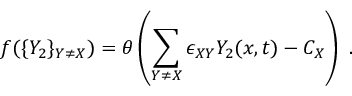Convert formula to latex. <formula><loc_0><loc_0><loc_500><loc_500>f ( \{ Y _ { 2 } \} _ { Y \neq X } ) = \boldsymbol \theta \left ( \sum _ { Y \neq X } \epsilon _ { X Y } Y _ { 2 } ( x , t ) - C _ { X } \right ) .</formula> 